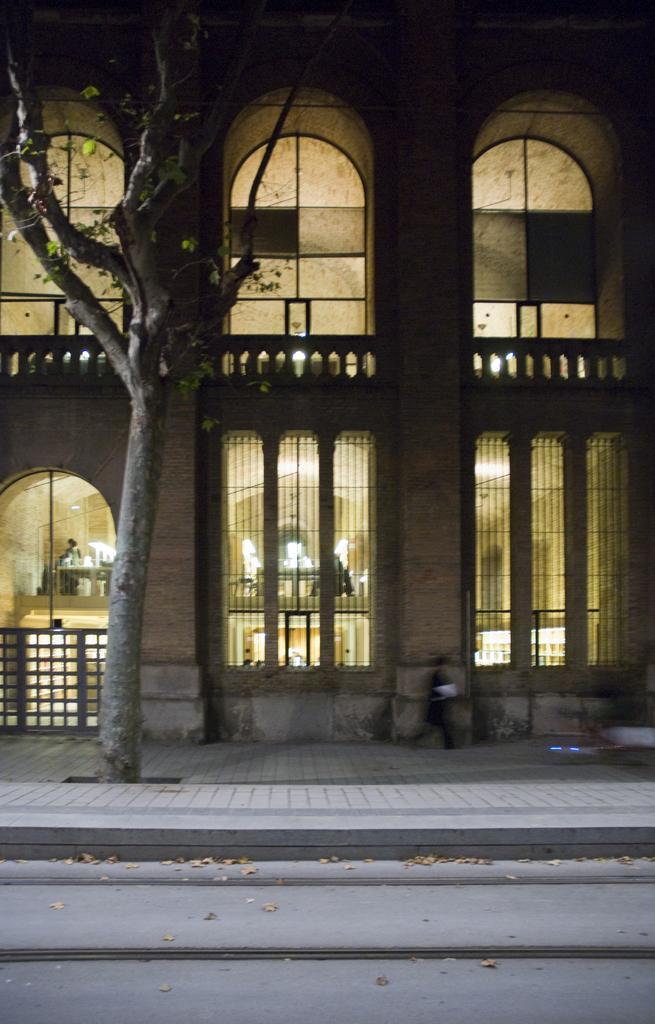In one or two sentences, can you explain what this image depicts? This image consists of a building. It has windows. There are lights in this image. There is a tree on the left side. 